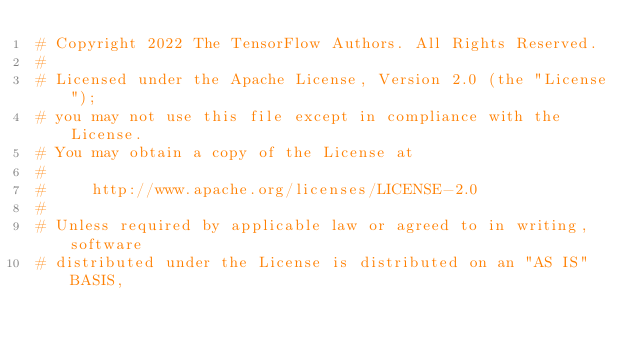<code> <loc_0><loc_0><loc_500><loc_500><_Python_># Copyright 2022 The TensorFlow Authors. All Rights Reserved.
#
# Licensed under the Apache License, Version 2.0 (the "License");
# you may not use this file except in compliance with the License.
# You may obtain a copy of the License at
#
#     http://www.apache.org/licenses/LICENSE-2.0
#
# Unless required by applicable law or agreed to in writing, software
# distributed under the License is distributed on an "AS IS" BASIS,</code> 